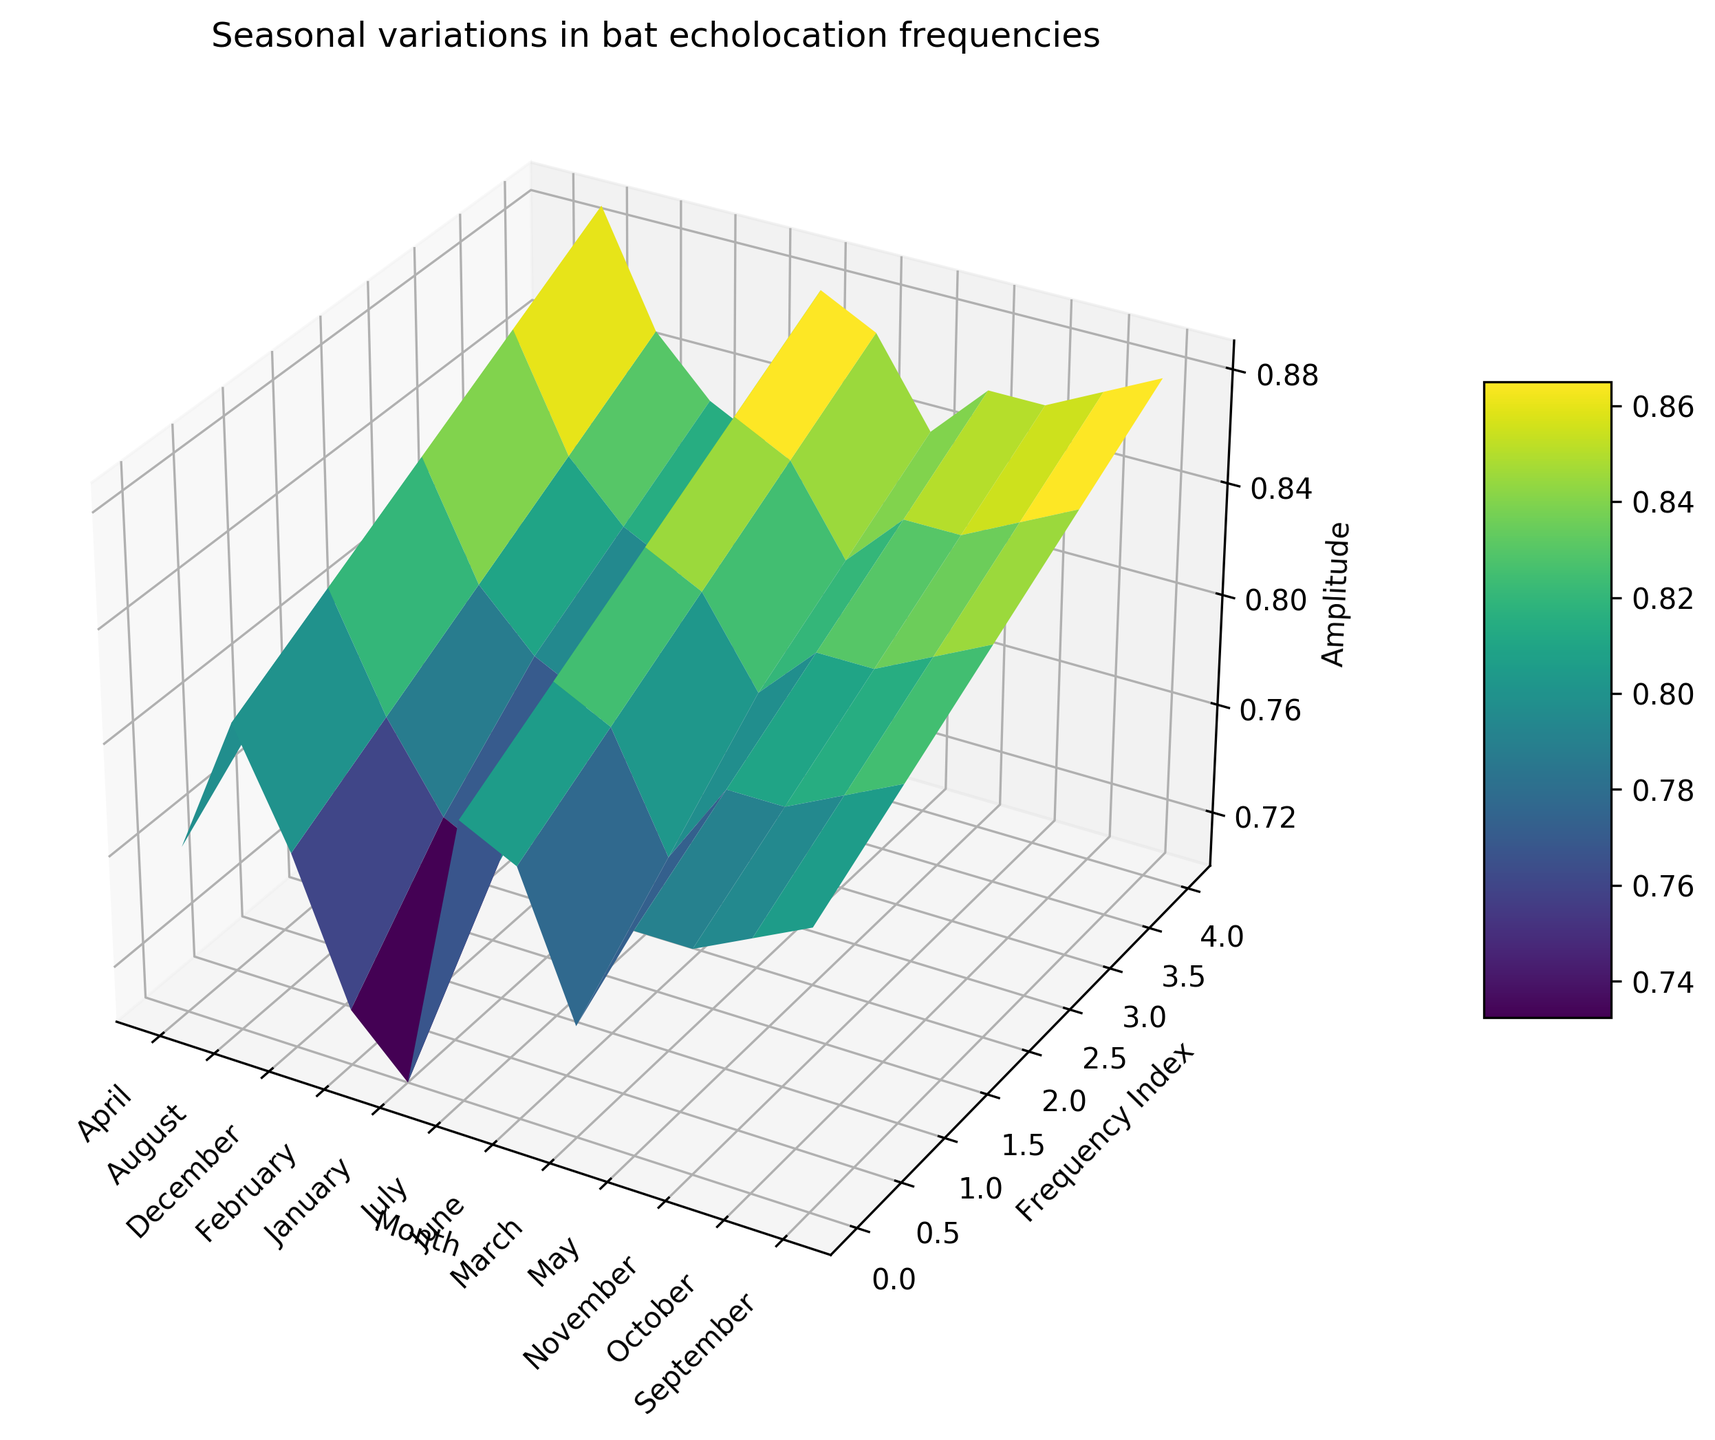Which month shows the highest peak in amplitude? To determine the month with the highest peak, observe the maximum point of the surface plot. The highest z-axis value, corresponding to the amplitude, is towards the end of the year. July has a peak amplitude of 0.88.
Answer: July During which month is the lowest amplitude observed, and what is it? Find the minimum point on the z-axis of the plot, which corresponds to the amplitude. The lowest amplitude appears at the beginning of the year. In January, the minimum amplitude is 0.70.
Answer: January, 0.70 How does the amplitude in March compare to that in September? Compare the z-axis value for March and September. Every month has an increasing amplitude pattern. However, March has slightly higher peak values compared to September (0.84 vs. 0.88).
Answer: March is lower than September What is the general trend in amplitude from January to December? By observing the surface plot from January to December, you notice an overall upward trend in amplitude, starting from around 0.7 and peaking close to 0.89.
Answer: Increasing trend Which month has the steepest rise in frequency with respect to amplitude? Assess the slope of the surface plot along the y-axis (frequency) while moving along the x-axis (month). The plot shows that during August, the amplitude rises sharply with frequency.
Answer: August Comparing April and October, which month shows higher amplitude values overall? By examining the plot, observe the range of amplitudes for both months. The plot shows heights of the peaks; October consistently shows weaker amplitude values compared to April.
Answer: April What is the change in amplitude from the frequency range of 35 to 38 kHz in January? Examine January on the plot and compare the z-axis values at 35 kHz (0.70) and 38 kHz (0.78). The difference in amplitude is 0.78 - 0.70.
Answer: 0.08 What colors do the highest amplitudes on the plot represent? Observe the hues corresponding to the highest peaks on the plot. The highest amplitudes are represented by a bright yellowish-green color.
Answer: Yellowish-green Which month shows the most stable amplitude across varying frequencies? Evaluate the z-axis consistency across the month in the plot. March demonstrates the most stable amplitude with relatively smaller variations compared to other months.
Answer: March What is the average amplitude for the month of June? Calculate the average of the z-axis values for June. The amplitudes are 0.79, 0.81, 0.83, 0.85, and 0.87. Summing these and dividing by 5 yields (0.79+0.81+0.83+0.85+0.87)/5.
Answer: 0.83 